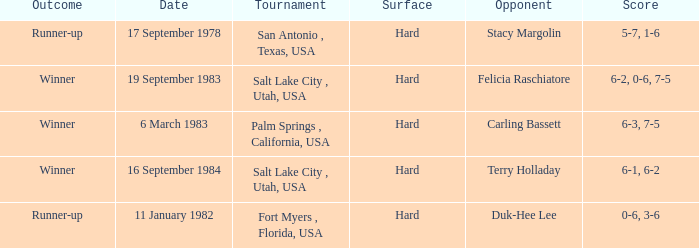In the contest against duk-hee lee, what was the score? 0-6, 3-6. 